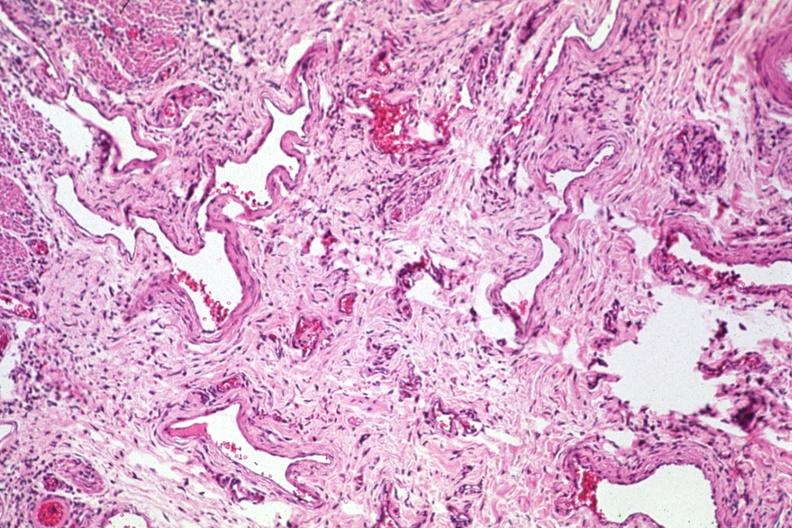s very good example present?
Answer the question using a single word or phrase. No 